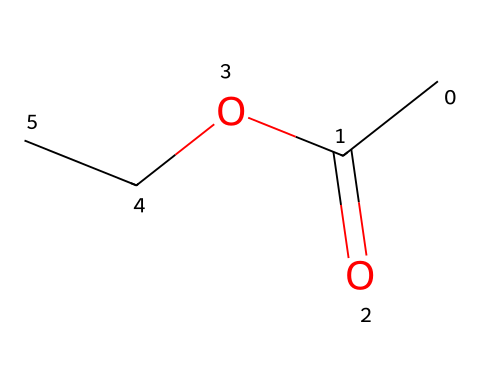What is the functional group present in ethyl acetate? The functional group is determined by the presence of a specific arrangement of atoms. In ethyl acetate, there is a carbonyl group (C=O) bonded to an oxygen atom (O) that is also attached to an ethyl group (C2H5). This structure defines it as an ester.
Answer: ester How many carbon atoms are in ethyl acetate? By analyzing the SMILES representation, "CC(=O)OCC", we can count the carbon atoms directly from the structure. There are two carbon atoms in the ethyl group (CC) and one carbon in the carbonyl (C=O), giving a total of four carbon atoms.
Answer: four What is the total number of hydrogen atoms in ethyl acetate? The hydrogen atoms can be deduced from the carbon and functional group arrangement. The ethyl group contributes five hydrogens, and the carbonyl group does not contribute any hydrogens. Thus, the total count is five.
Answer: five What type of reaction can form ethyl acetate? Ethyl acetate can form through an esterification reaction, which involves the reaction of an alcohol and an acid. Specifically, acetic acid reacts with ethanol to yield ethyl acetate and water.
Answer: esterification What is the molecular formula of ethyl acetate? The molecular formula can be derived from the counts of each atom: We have four carbons (C), eight hydrogens (H), and two oxygens (O). Hence, combining these gives us the formula C4H8O2.
Answer: C4H8O2 What kind of intermolecular forces are present in ethyl acetate? By examining the molecular structure, ethyl acetate has polar covalent bonds due to the carbonyl (C=O) oxygen and shows dipole-dipole interactions and Van der Waals forces. The presence of the polar carbonyl indicates dipole-dipole forces primarily dominate.
Answer: dipole-dipole Why is ethyl acetate a common solvent in biomaterials? Ethyl acetate is commonly used as a solvent due to its good solvency properties for a range of biomaterials, its relatively low toxicity, and its ability to evaporate quickly, which is essential in applications involving polymers and other materials.
Answer: good solvency 